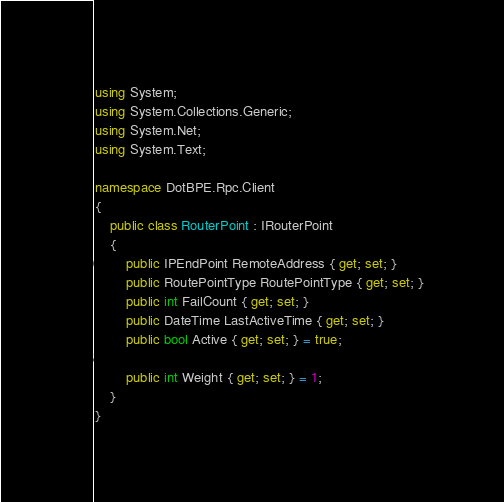Convert code to text. <code><loc_0><loc_0><loc_500><loc_500><_C#_>using System;
using System.Collections.Generic;
using System.Net;
using System.Text;

namespace DotBPE.Rpc.Client
{
    public class RouterPoint : IRouterPoint
    {
        public IPEndPoint RemoteAddress { get; set; }
        public RoutePointType RoutePointType { get; set; }
        public int FailCount { get; set; }
        public DateTime LastActiveTime { get; set; }
        public bool Active { get; set; } = true;

        public int Weight { get; set; } = 1;
    }
}
</code> 